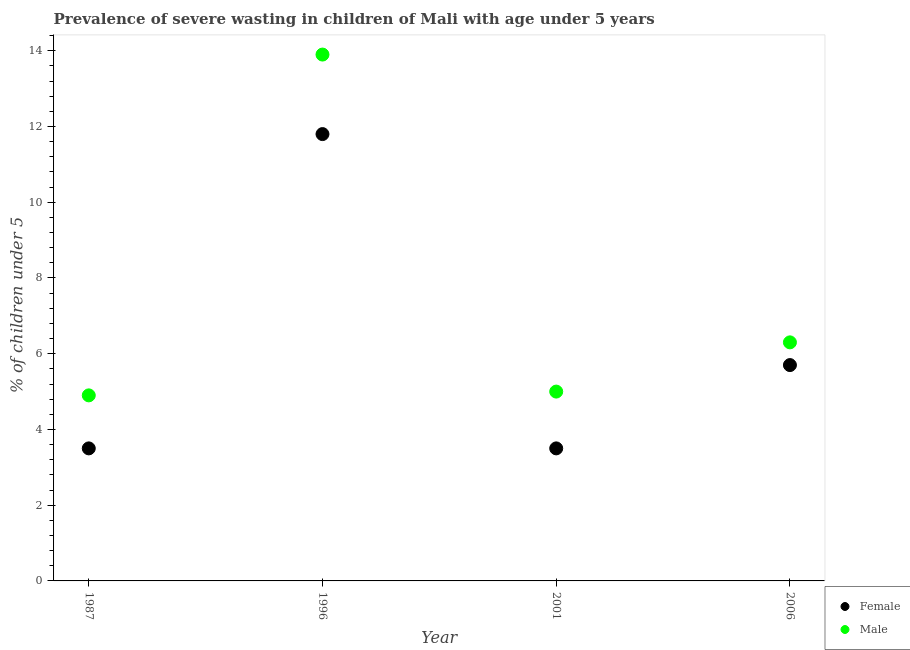What is the percentage of undernourished male children in 1987?
Provide a short and direct response. 4.9. Across all years, what is the maximum percentage of undernourished male children?
Make the answer very short. 13.9. What is the total percentage of undernourished female children in the graph?
Keep it short and to the point. 24.5. What is the difference between the percentage of undernourished female children in 1987 and that in 1996?
Make the answer very short. -8.3. What is the difference between the percentage of undernourished female children in 2001 and the percentage of undernourished male children in 2006?
Provide a short and direct response. -2.8. What is the average percentage of undernourished female children per year?
Ensure brevity in your answer.  6.13. In the year 1987, what is the difference between the percentage of undernourished female children and percentage of undernourished male children?
Provide a succinct answer. -1.4. What is the ratio of the percentage of undernourished female children in 1996 to that in 2001?
Give a very brief answer. 3.37. Is the difference between the percentage of undernourished female children in 2001 and 2006 greater than the difference between the percentage of undernourished male children in 2001 and 2006?
Provide a succinct answer. No. What is the difference between the highest and the second highest percentage of undernourished female children?
Your answer should be very brief. 6.1. What is the difference between the highest and the lowest percentage of undernourished male children?
Make the answer very short. 9. Is the sum of the percentage of undernourished male children in 1996 and 2006 greater than the maximum percentage of undernourished female children across all years?
Provide a succinct answer. Yes. Is the percentage of undernourished male children strictly less than the percentage of undernourished female children over the years?
Your answer should be compact. No. How many dotlines are there?
Provide a short and direct response. 2. What is the difference between two consecutive major ticks on the Y-axis?
Your answer should be very brief. 2. Are the values on the major ticks of Y-axis written in scientific E-notation?
Your response must be concise. No. How many legend labels are there?
Give a very brief answer. 2. How are the legend labels stacked?
Your answer should be compact. Vertical. What is the title of the graph?
Provide a short and direct response. Prevalence of severe wasting in children of Mali with age under 5 years. Does "Female labourers" appear as one of the legend labels in the graph?
Provide a short and direct response. No. What is the label or title of the Y-axis?
Provide a succinct answer.  % of children under 5. What is the  % of children under 5 of Male in 1987?
Ensure brevity in your answer.  4.9. What is the  % of children under 5 in Female in 1996?
Your answer should be very brief. 11.8. What is the  % of children under 5 of Male in 1996?
Your response must be concise. 13.9. What is the  % of children under 5 of Male in 2001?
Make the answer very short. 5. What is the  % of children under 5 in Female in 2006?
Your answer should be compact. 5.7. What is the  % of children under 5 in Male in 2006?
Your response must be concise. 6.3. Across all years, what is the maximum  % of children under 5 of Female?
Offer a very short reply. 11.8. Across all years, what is the maximum  % of children under 5 in Male?
Your answer should be compact. 13.9. Across all years, what is the minimum  % of children under 5 in Female?
Provide a short and direct response. 3.5. Across all years, what is the minimum  % of children under 5 of Male?
Ensure brevity in your answer.  4.9. What is the total  % of children under 5 in Female in the graph?
Your response must be concise. 24.5. What is the total  % of children under 5 of Male in the graph?
Your answer should be compact. 30.1. What is the difference between the  % of children under 5 of Female in 1987 and that in 1996?
Give a very brief answer. -8.3. What is the difference between the  % of children under 5 in Male in 1987 and that in 1996?
Your response must be concise. -9. What is the difference between the  % of children under 5 of Male in 1987 and that in 2001?
Provide a succinct answer. -0.1. What is the difference between the  % of children under 5 of Female in 1987 and that in 2006?
Offer a terse response. -2.2. What is the difference between the  % of children under 5 in Male in 1987 and that in 2006?
Ensure brevity in your answer.  -1.4. What is the difference between the  % of children under 5 of Female in 1996 and that in 2001?
Make the answer very short. 8.3. What is the difference between the  % of children under 5 in Female in 1996 and that in 2006?
Your response must be concise. 6.1. What is the difference between the  % of children under 5 in Male in 1996 and that in 2006?
Your answer should be very brief. 7.6. What is the difference between the  % of children under 5 of Female in 2001 and that in 2006?
Provide a short and direct response. -2.2. What is the difference between the  % of children under 5 of Male in 2001 and that in 2006?
Provide a succinct answer. -1.3. What is the difference between the  % of children under 5 in Female in 1987 and the  % of children under 5 in Male in 1996?
Offer a very short reply. -10.4. What is the difference between the  % of children under 5 of Female in 1987 and the  % of children under 5 of Male in 2006?
Ensure brevity in your answer.  -2.8. What is the difference between the  % of children under 5 of Female in 1996 and the  % of children under 5 of Male in 2001?
Provide a short and direct response. 6.8. What is the difference between the  % of children under 5 of Female in 2001 and the  % of children under 5 of Male in 2006?
Ensure brevity in your answer.  -2.8. What is the average  % of children under 5 in Female per year?
Your response must be concise. 6.12. What is the average  % of children under 5 in Male per year?
Make the answer very short. 7.53. In the year 1987, what is the difference between the  % of children under 5 of Female and  % of children under 5 of Male?
Offer a terse response. -1.4. In the year 1996, what is the difference between the  % of children under 5 in Female and  % of children under 5 in Male?
Give a very brief answer. -2.1. In the year 2001, what is the difference between the  % of children under 5 of Female and  % of children under 5 of Male?
Your response must be concise. -1.5. In the year 2006, what is the difference between the  % of children under 5 of Female and  % of children under 5 of Male?
Offer a very short reply. -0.6. What is the ratio of the  % of children under 5 of Female in 1987 to that in 1996?
Your answer should be very brief. 0.3. What is the ratio of the  % of children under 5 of Male in 1987 to that in 1996?
Provide a succinct answer. 0.35. What is the ratio of the  % of children under 5 in Female in 1987 to that in 2001?
Offer a very short reply. 1. What is the ratio of the  % of children under 5 in Male in 1987 to that in 2001?
Your response must be concise. 0.98. What is the ratio of the  % of children under 5 in Female in 1987 to that in 2006?
Your answer should be very brief. 0.61. What is the ratio of the  % of children under 5 of Female in 1996 to that in 2001?
Give a very brief answer. 3.37. What is the ratio of the  % of children under 5 in Male in 1996 to that in 2001?
Your answer should be very brief. 2.78. What is the ratio of the  % of children under 5 in Female in 1996 to that in 2006?
Provide a succinct answer. 2.07. What is the ratio of the  % of children under 5 of Male in 1996 to that in 2006?
Give a very brief answer. 2.21. What is the ratio of the  % of children under 5 in Female in 2001 to that in 2006?
Give a very brief answer. 0.61. What is the ratio of the  % of children under 5 of Male in 2001 to that in 2006?
Make the answer very short. 0.79. What is the difference between the highest and the lowest  % of children under 5 in Female?
Offer a very short reply. 8.3. 